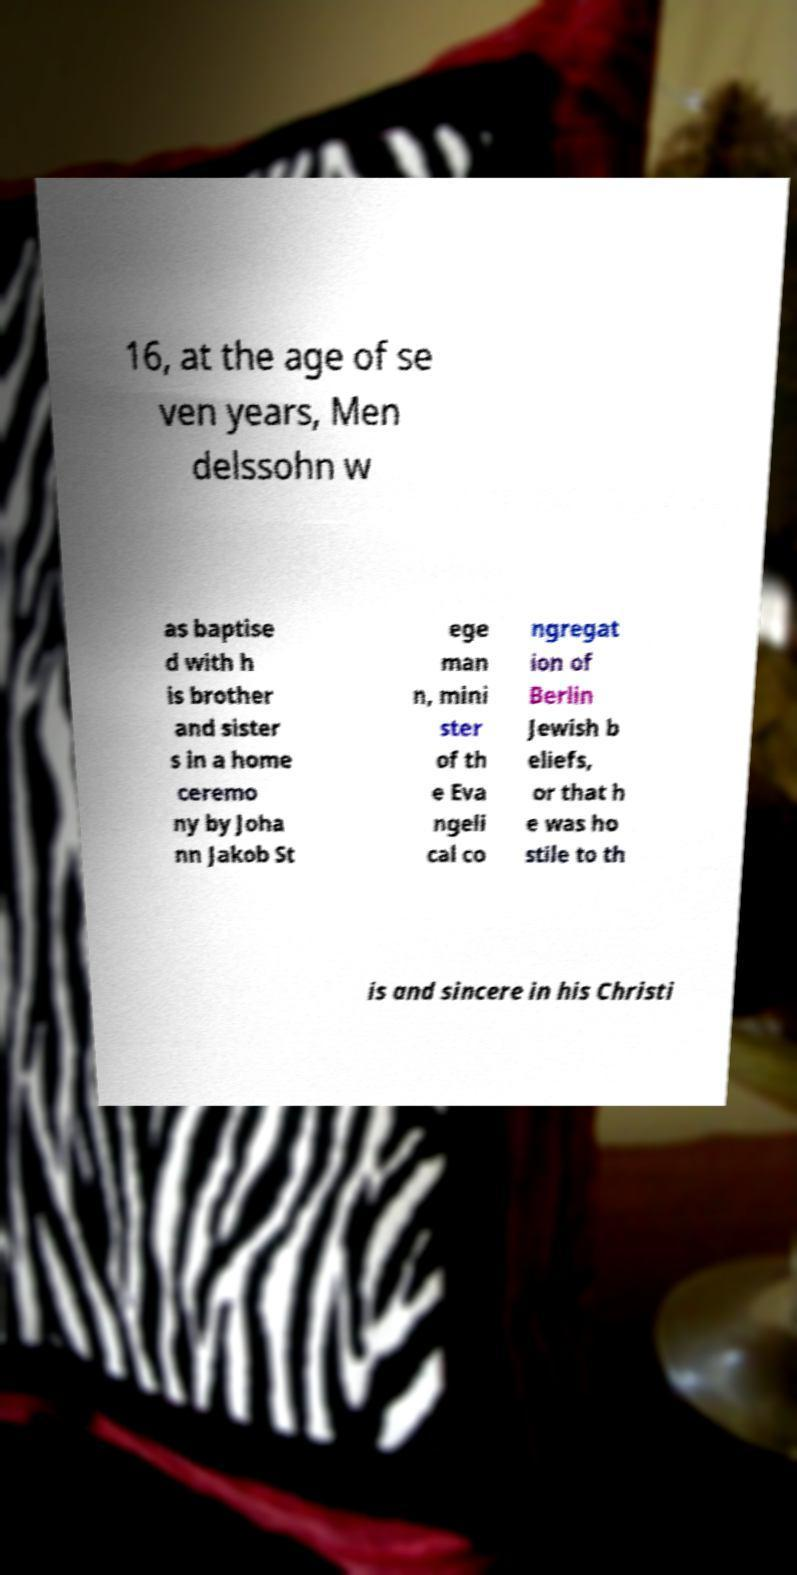Could you assist in decoding the text presented in this image and type it out clearly? 16, at the age of se ven years, Men delssohn w as baptise d with h is brother and sister s in a home ceremo ny by Joha nn Jakob St ege man n, mini ster of th e Eva ngeli cal co ngregat ion of Berlin Jewish b eliefs, or that h e was ho stile to th is and sincere in his Christi 